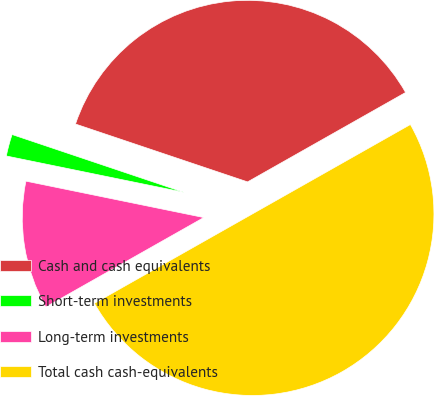Convert chart to OTSL. <chart><loc_0><loc_0><loc_500><loc_500><pie_chart><fcel>Cash and cash equivalents<fcel>Short-term investments<fcel>Long-term investments<fcel>Total cash cash-equivalents<nl><fcel>36.64%<fcel>1.95%<fcel>11.41%<fcel>50.0%<nl></chart> 